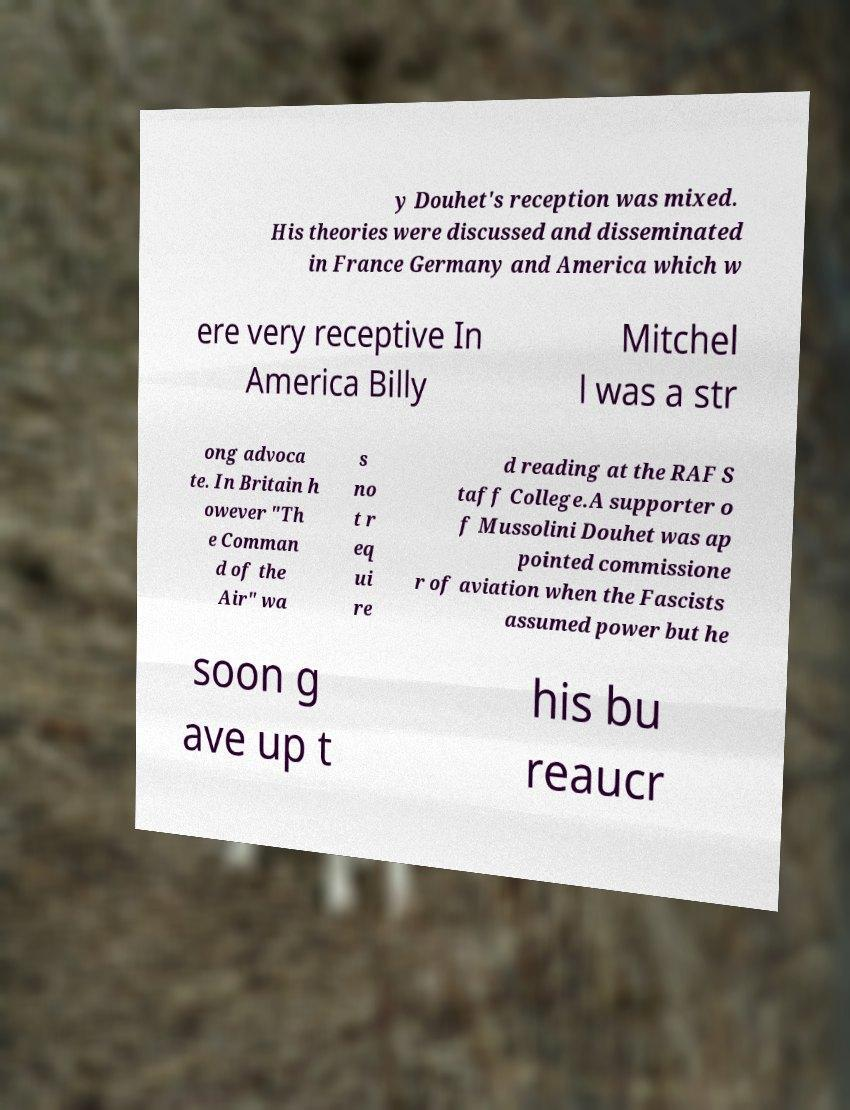Please read and relay the text visible in this image. What does it say? y Douhet's reception was mixed. His theories were discussed and disseminated in France Germany and America which w ere very receptive In America Billy Mitchel l was a str ong advoca te. In Britain h owever "Th e Comman d of the Air" wa s no t r eq ui re d reading at the RAF S taff College.A supporter o f Mussolini Douhet was ap pointed commissione r of aviation when the Fascists assumed power but he soon g ave up t his bu reaucr 